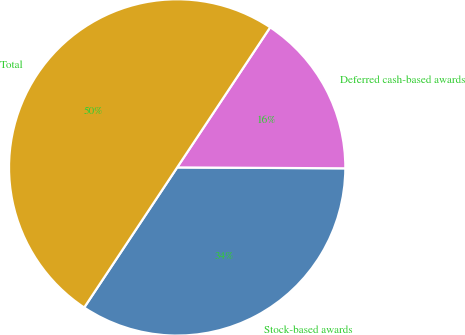Convert chart to OTSL. <chart><loc_0><loc_0><loc_500><loc_500><pie_chart><fcel>Stock-based awards<fcel>Deferred cash-based awards<fcel>Total<nl><fcel>34.24%<fcel>15.76%<fcel>50.0%<nl></chart> 